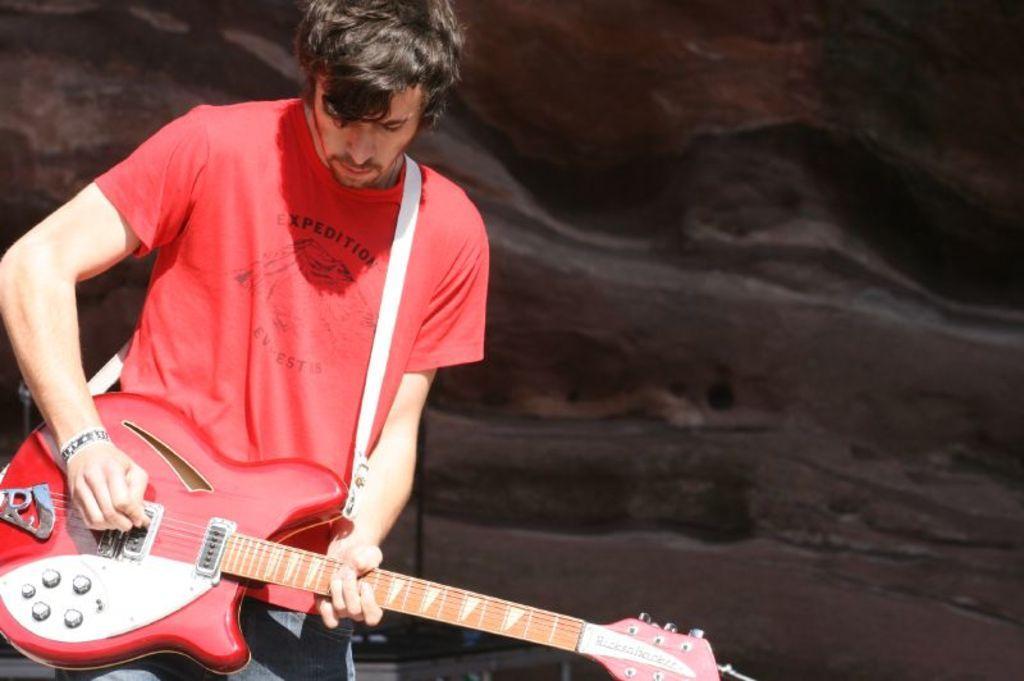How would you summarize this image in a sentence or two? On the left side of the image a man is standing and he is holding a guitar in his hands. He is playing a music with guitar. In this image the background is black in color. 